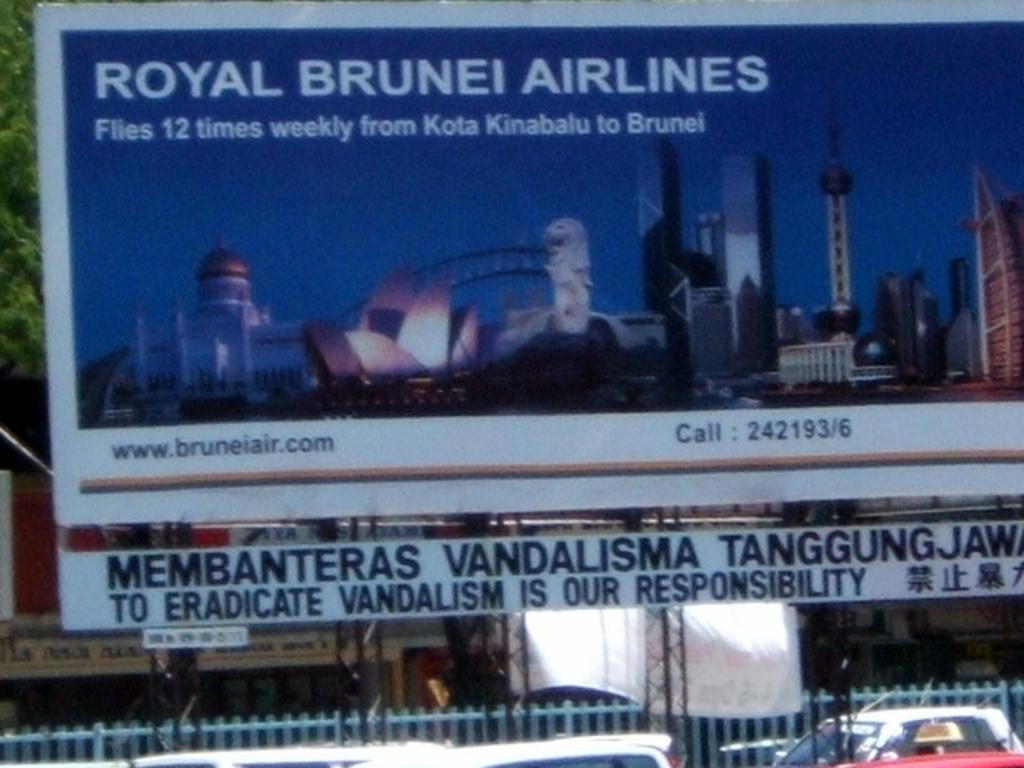Provide a one-sentence caption for the provided image. A Royal Brunei Airlines advertisement that states how many times they fly from Kota Kinabulu to Brunei. 